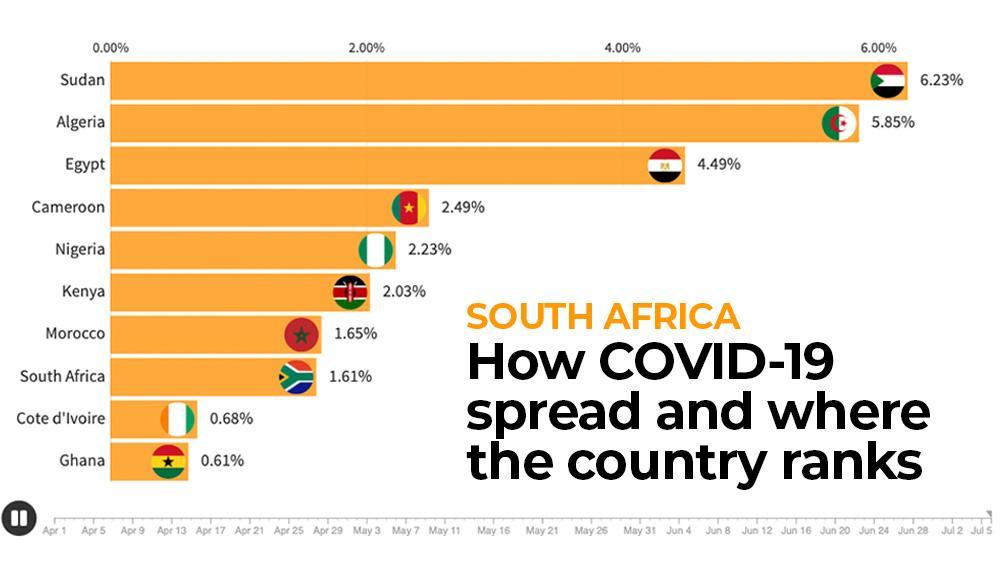What is the rank of Cameroon in Covid-19 spread?
Answer the question with a short phrase. 4 How many countries in South Africa has Covid cases greater than 4%? 3 Which South African country ranks third position in Covid-19 spread? Egypt How much the disease spread of South Africa is less than Morocco? 0.04 How much the disease spread of Algeria is less than Sudan? 0.38 Which are the countries with Covid cases in the range 1 - 2 percentage? Morocco, South Africa How many countries in South Africa has Covid cases greater than 5%? 2 Which country has the 7th rank in no of Covid cases? Morocco Which are the countries in South Africa with Covid cases less than 1%? Cote d'Ivoire, Ghana Which is the country with second lowest no of corona cases? Cote d'Ivoire 